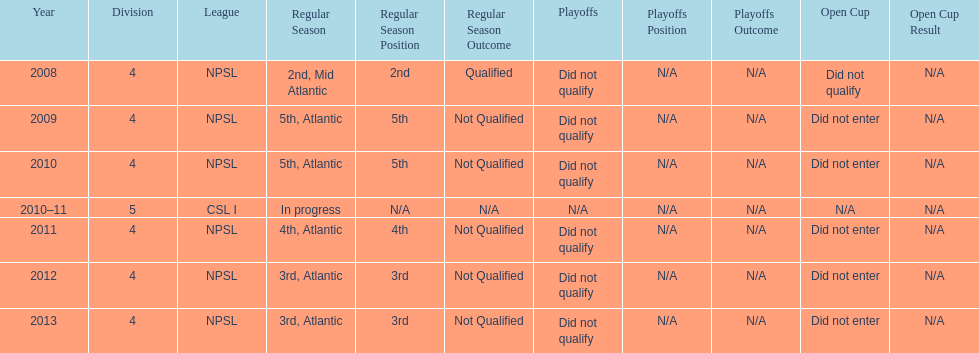How many 3rd place finishes has npsl had? 2. 